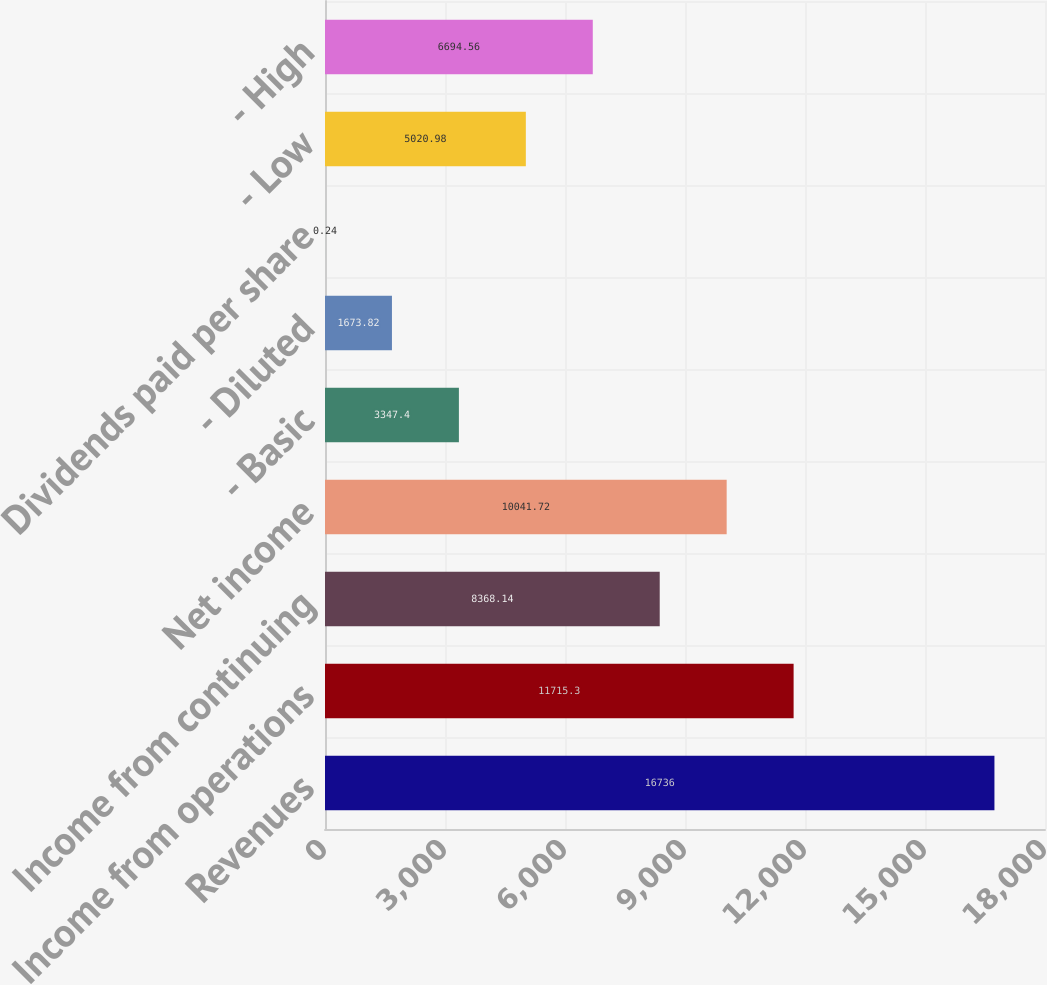Convert chart to OTSL. <chart><loc_0><loc_0><loc_500><loc_500><bar_chart><fcel>Revenues<fcel>Income from operations<fcel>Income from continuing<fcel>Net income<fcel>- Basic<fcel>- Diluted<fcel>Dividends paid per share<fcel>- Low<fcel>- High<nl><fcel>16736<fcel>11715.3<fcel>8368.14<fcel>10041.7<fcel>3347.4<fcel>1673.82<fcel>0.24<fcel>5020.98<fcel>6694.56<nl></chart> 